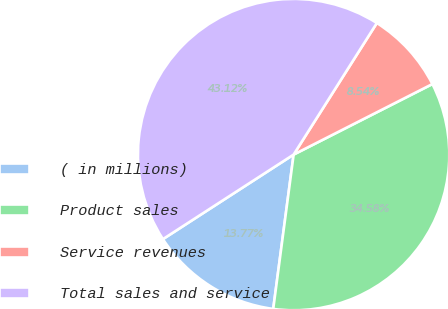Convert chart to OTSL. <chart><loc_0><loc_0><loc_500><loc_500><pie_chart><fcel>( in millions)<fcel>Product sales<fcel>Service revenues<fcel>Total sales and service<nl><fcel>13.77%<fcel>34.58%<fcel>8.54%<fcel>43.12%<nl></chart> 